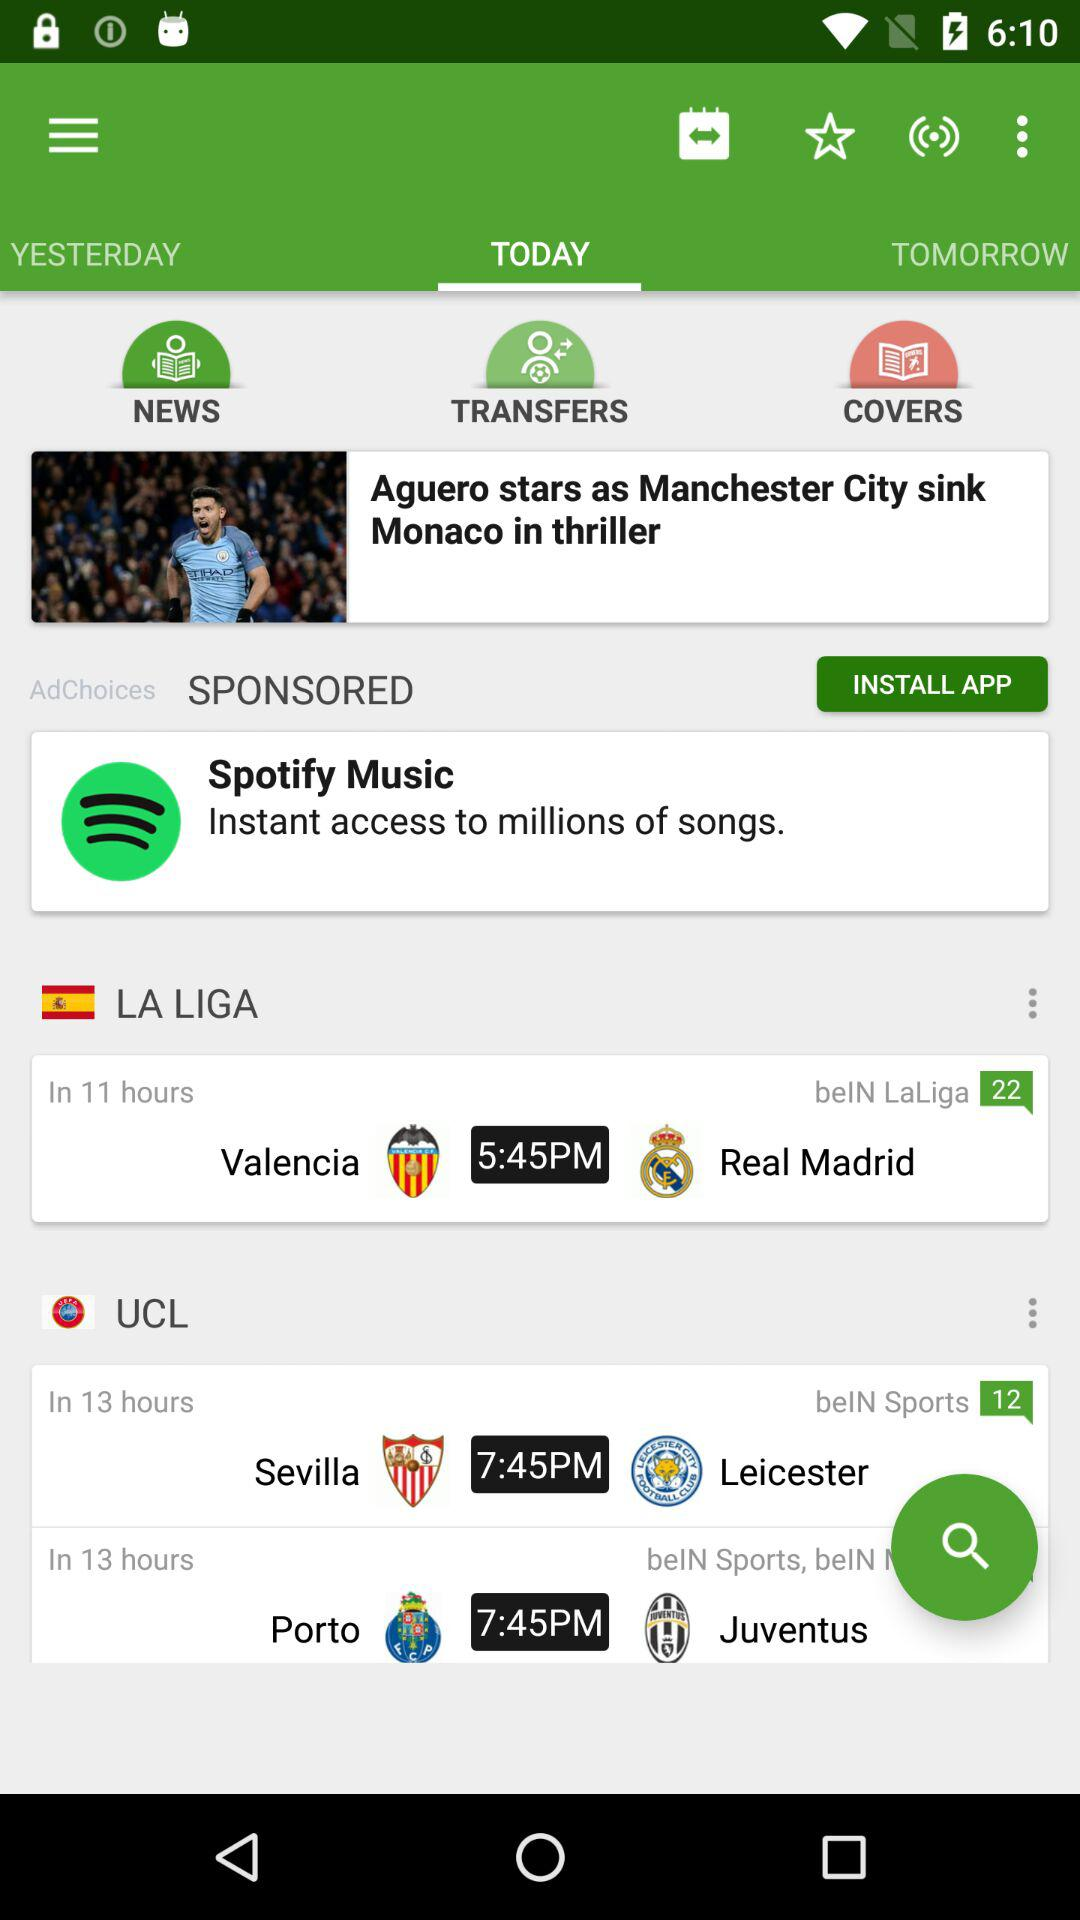How many more games are in the UCL than the La Liga?
Answer the question using a single word or phrase. 1 